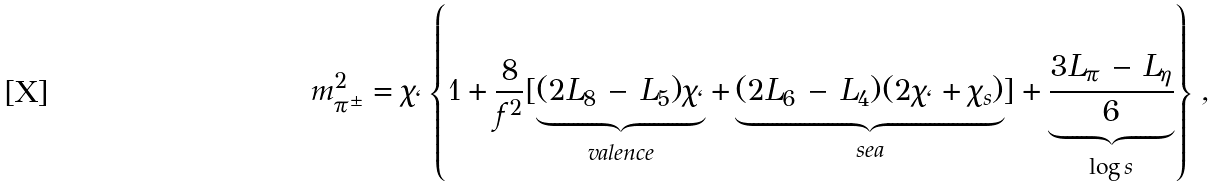Convert formula to latex. <formula><loc_0><loc_0><loc_500><loc_500>m _ { \pi ^ { \pm } } ^ { 2 } = \chi _ { \ell } \left \{ 1 + \frac { 8 } { f ^ { 2 } } [ \underbrace { { ( 2 L _ { 8 } \, - \, L _ { 5 } ) } \chi _ { \ell } } _ { v a l e n c e } + \underbrace { { ( 2 L _ { 6 } \, - \, L _ { 4 } ) } ( 2 \chi _ { \ell } + \chi _ { s } ) } _ { s e a } ] + \underbrace { \frac { 3 L _ { \pi } \, - \, L _ { \eta } } { 6 } } _ { \log s } \right \} \, ,</formula> 